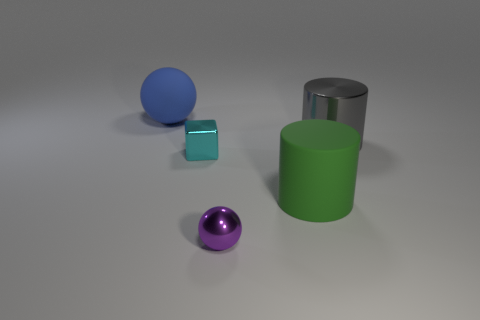Are there any big objects that have the same material as the blue ball?
Your answer should be compact. Yes. How many purple things are small balls or big rubber cylinders?
Give a very brief answer. 1. Are there more big matte balls in front of the cyan thing than purple shiny balls?
Provide a short and direct response. No. Do the gray shiny object and the matte cylinder have the same size?
Your response must be concise. Yes. What color is the ball that is the same material as the gray object?
Offer a terse response. Purple. Are there the same number of big matte spheres to the right of the large gray shiny thing and blue balls that are on the right side of the large blue matte thing?
Offer a very short reply. Yes. What shape is the big thing that is left of the rubber object on the right side of the purple object?
Your response must be concise. Sphere. There is another object that is the same shape as the gray thing; what is it made of?
Your answer should be compact. Rubber. What is the color of the thing that is the same size as the cube?
Offer a very short reply. Purple. Is the number of big gray shiny cylinders that are right of the big green thing the same as the number of shiny cylinders?
Your answer should be very brief. Yes. 